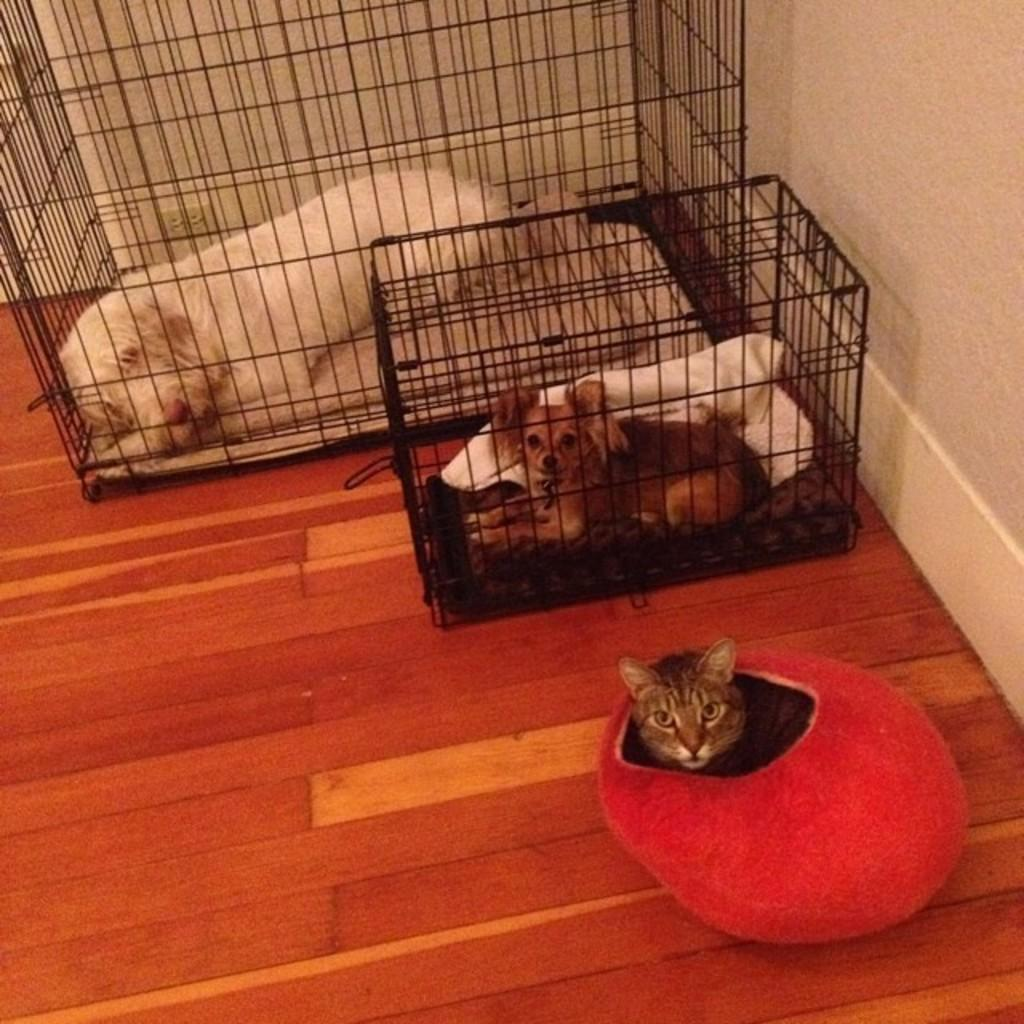What type of animals can be seen in the image? There is a dog, a puppy, and a cat in the image. How are the dog and puppy situated in the image? Both the dog and puppy are placed in cages. Where is the cat located in the image? The cat is sitting in a red box. What is the color of the wall on the right side of the image? The wall on the right side of the image is white. Can you tell me how many times the cat has touched the alley in the image? There is no alley present in the image, and therefore no such interaction can be observed. 